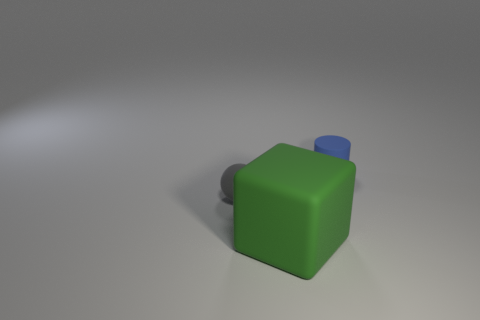There is a tiny blue matte cylinder; how many blocks are on the left side of it?
Your answer should be very brief. 1. There is a matte thing that is behind the big green matte object and in front of the blue rubber object; how big is it?
Your response must be concise. Small. Is there a green matte cube?
Keep it short and to the point. Yes. What number of other things are there of the same size as the green rubber cube?
Give a very brief answer. 0. There is a tiny rubber object to the right of the small ball; does it have the same color as the small matte thing that is to the left of the tiny matte cylinder?
Offer a very short reply. No. Are the tiny thing in front of the tiny blue thing and the object that is on the right side of the big green rubber thing made of the same material?
Provide a succinct answer. Yes. How many metallic objects are either tiny spheres or big objects?
Offer a terse response. 0. There is a blue cylinder that is right of the tiny matte object that is in front of the small object that is on the right side of the small sphere; what is it made of?
Your answer should be compact. Rubber. Is the shape of the small rubber object behind the tiny gray thing the same as the tiny thing in front of the matte cylinder?
Give a very brief answer. No. There is a rubber object that is to the right of the green thing that is to the right of the small gray rubber ball; what color is it?
Keep it short and to the point. Blue. 